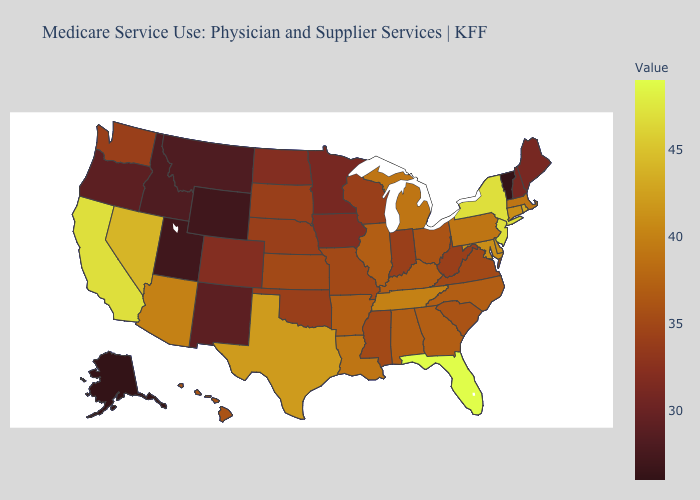Among the states that border Ohio , which have the highest value?
Be succinct. Michigan, Pennsylvania. Among the states that border North Carolina , does Tennessee have the lowest value?
Keep it brief. No. 